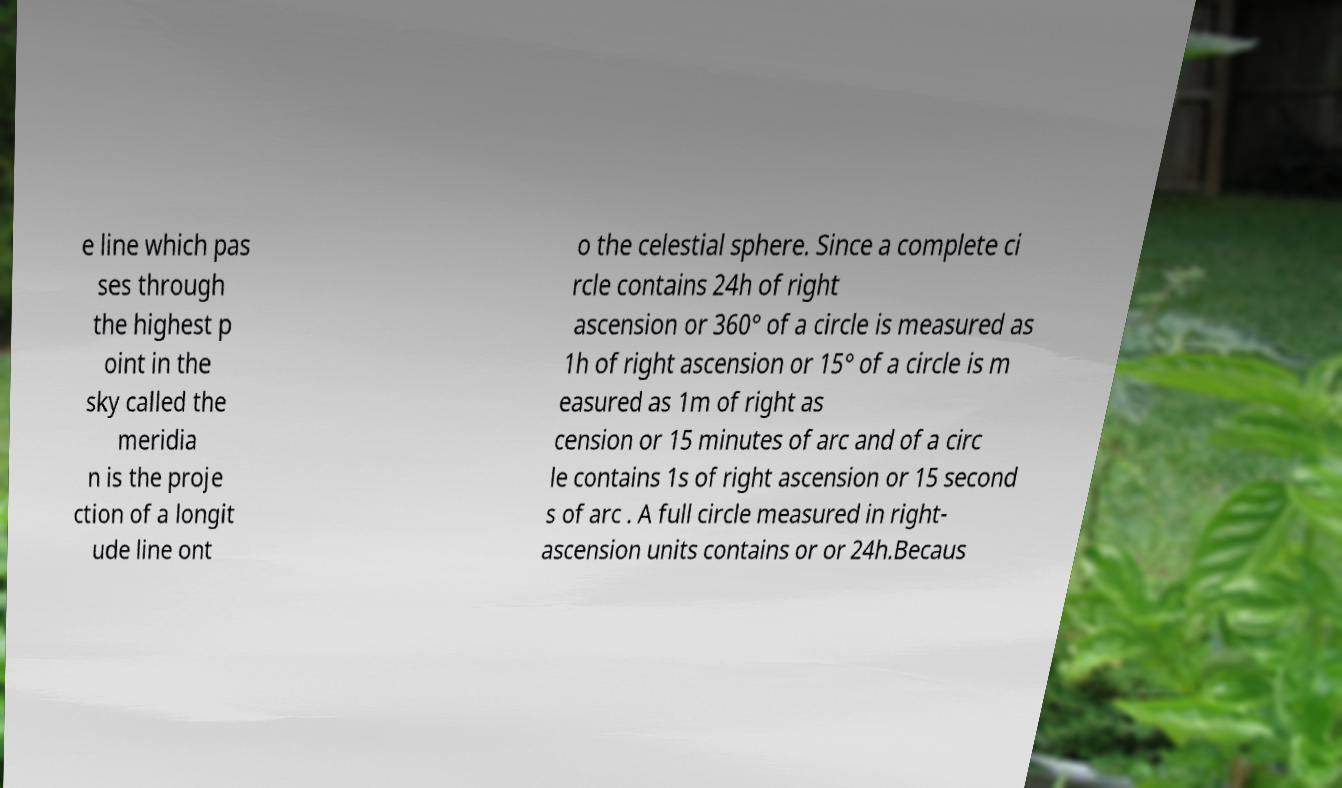Can you read and provide the text displayed in the image?This photo seems to have some interesting text. Can you extract and type it out for me? e line which pas ses through the highest p oint in the sky called the meridia n is the proje ction of a longit ude line ont o the celestial sphere. Since a complete ci rcle contains 24h of right ascension or 360° of a circle is measured as 1h of right ascension or 15° of a circle is m easured as 1m of right as cension or 15 minutes of arc and of a circ le contains 1s of right ascension or 15 second s of arc . A full circle measured in right- ascension units contains or or 24h.Becaus 